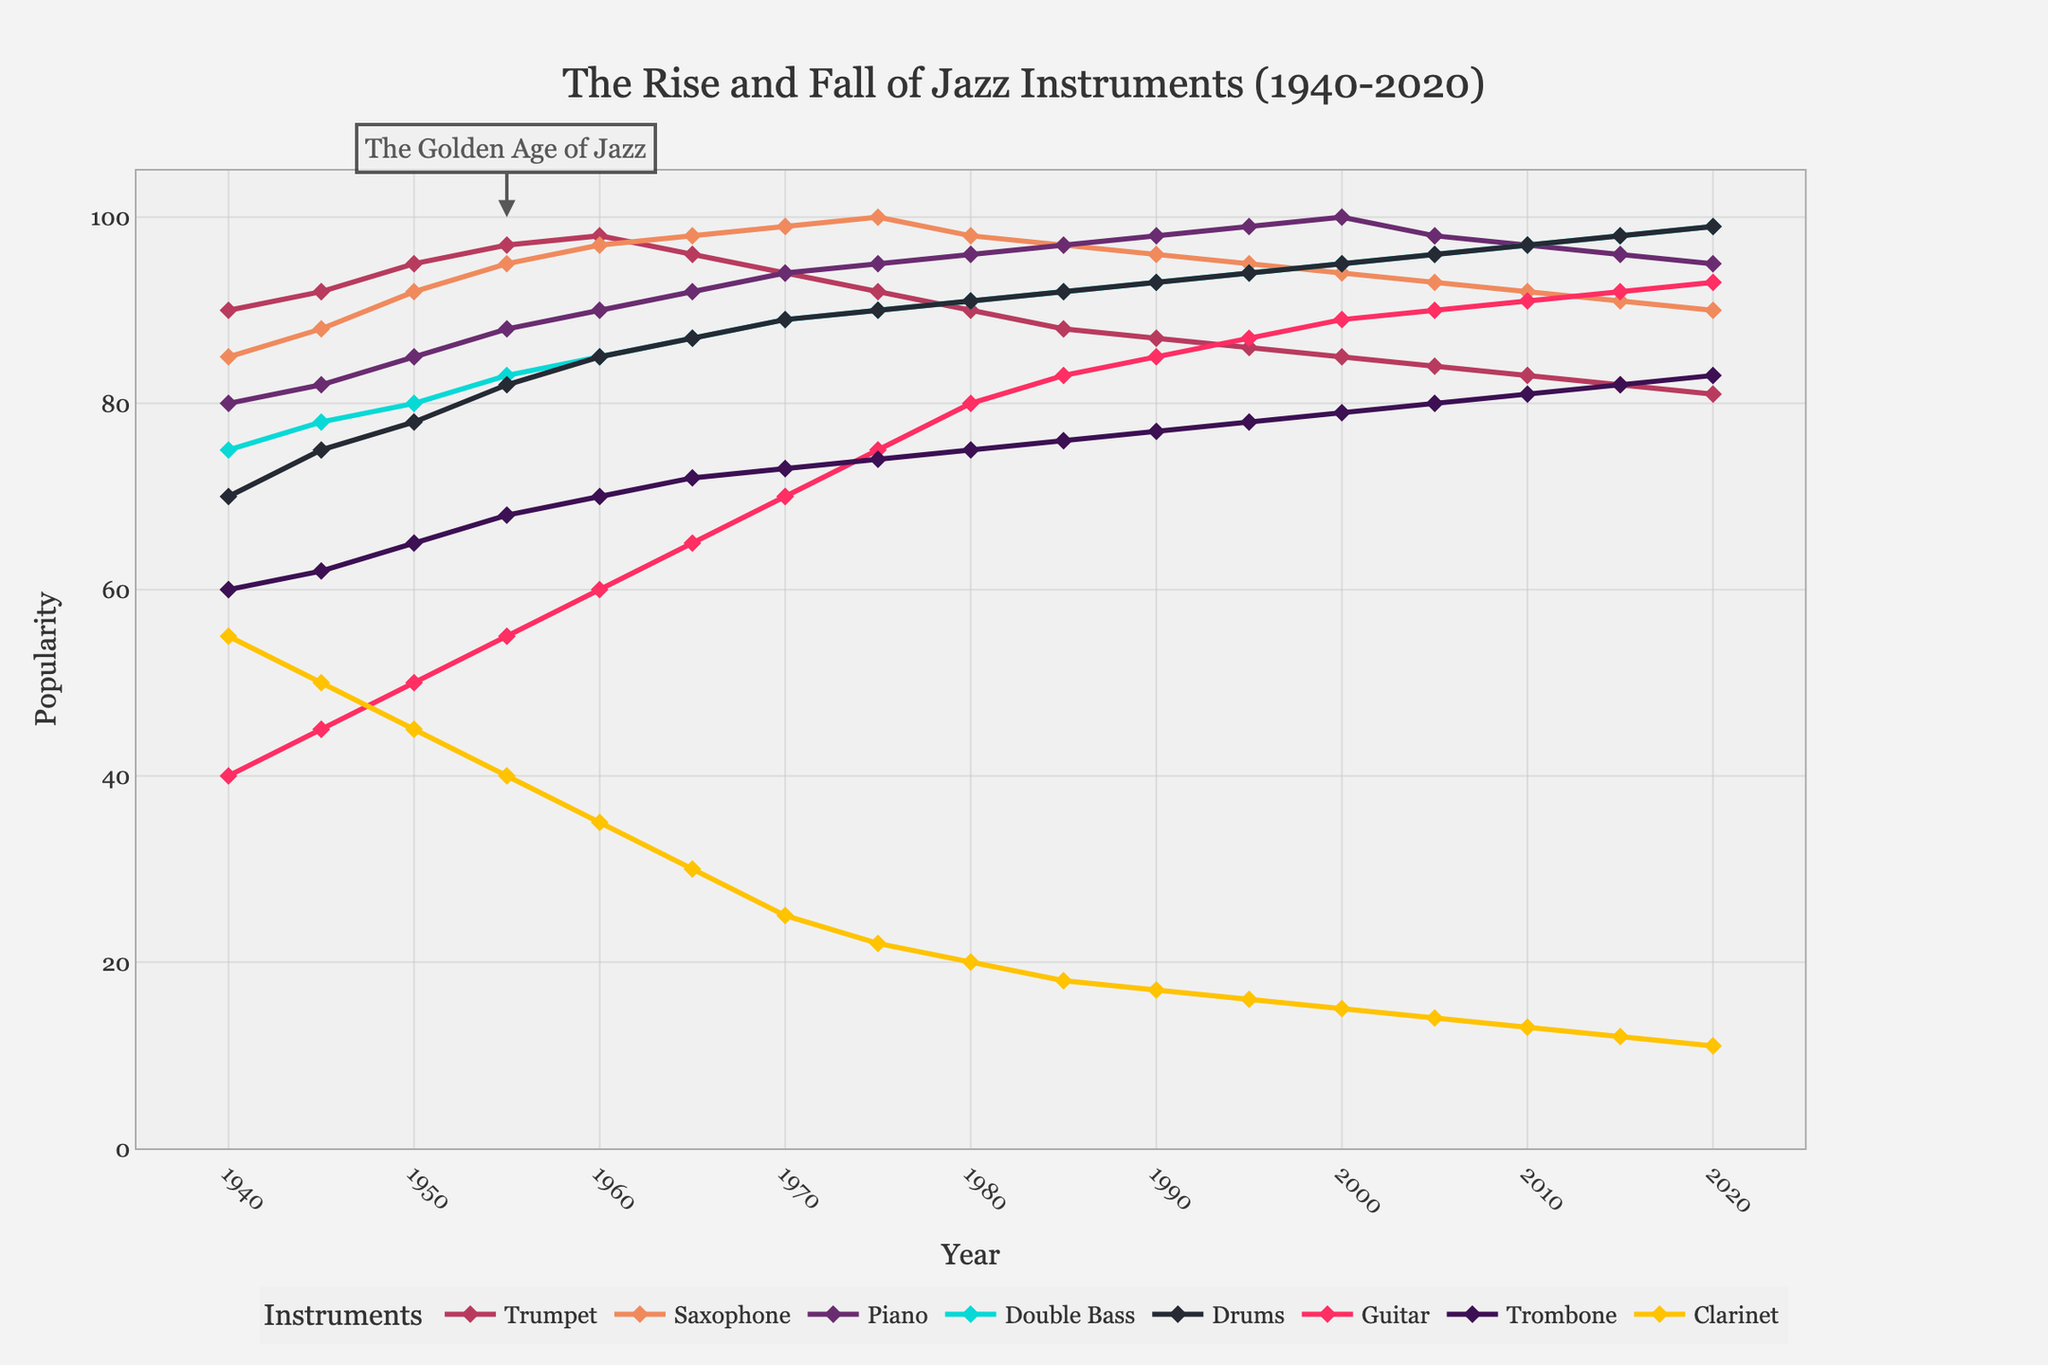What instrument was more popular in 2020, the Piano or the Trumpet? Look at the endpoints for the Piano and Trumpet lines in 2020. The Piano line ends higher than the Trumpet line.
Answer: Piano Between 1940 and 2020, which instrument had the largest increase in popularity? Calculate the difference between the values in 2020 and 1940 for each instrument. Piano increased from 80 to 100 (20 points), which is the largest increase.
Answer: Piano In which year did the Saxophone first surpass 95 in popularity? Follow the Saxophone line and spot the first mark where it crosses 95, which happens in the year 1965.
Answer: 1965 What's the average popularity of the Double Bass from 1980 to 2020? Sum the values of Double Bass from 1980 to 2020 (91 + 92 + 93 + 94 + 95 + 96 + 97 + 98 + 99) and divide by the number of years (9). (91+92+93+94+95+96+97+98+99) / 9 = 95
Answer: 95 Which instrument declined most sharply in popularity between 1965 and 1980? Calculate the decline for each instrument from 1965 to 1980. Clarinet drops from 30 to 20, the sharpest decline of 10 points.
Answer: Clarinet What was the relative popularity of Drums compared to Guitar in 2000? Compare the points for Drums (95) and Guitar (89) in 2000; Drums is more popular.
Answer: Drums How much more popular was the Trombone in 2020 compared to 1940? Subtract Trombone's 1940 value from its 2020 value: 83 - 60 = 23.
Answer: 23 During which period did Trumpet lose popularity after reaching its peak? Identify Trumpet's peak value at 1960 (98) and observe its decline in the following years. It starts decreasing from 1960 onward.
Answer: After 1960 Which instrument maintained a near-linear increase in popularity from 1940 to 2020? Analyze trends and note that the Piano has a nearly linear increase in popularity over this period.
Answer: Piano When did the Guitar surpass a popularity value of 80? Locate the point on the Guitar line where it first surpasses 80, which occurs in the year 1980.
Answer: 1980 